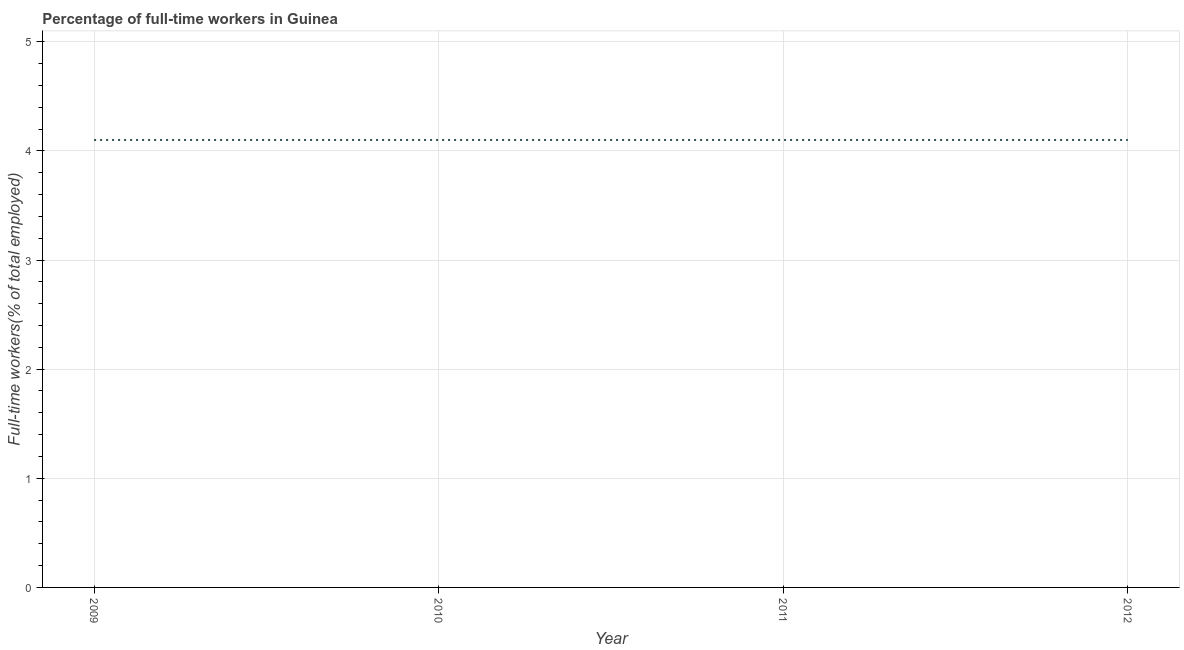What is the percentage of full-time workers in 2009?
Offer a very short reply. 4.1. Across all years, what is the maximum percentage of full-time workers?
Your response must be concise. 4.1. Across all years, what is the minimum percentage of full-time workers?
Make the answer very short. 4.1. In which year was the percentage of full-time workers maximum?
Make the answer very short. 2009. In which year was the percentage of full-time workers minimum?
Your answer should be compact. 2009. What is the sum of the percentage of full-time workers?
Offer a terse response. 16.4. What is the average percentage of full-time workers per year?
Ensure brevity in your answer.  4.1. What is the median percentage of full-time workers?
Ensure brevity in your answer.  4.1. Do a majority of the years between 2010 and 2012 (inclusive) have percentage of full-time workers greater than 2 %?
Provide a succinct answer. Yes. What is the ratio of the percentage of full-time workers in 2010 to that in 2011?
Offer a very short reply. 1. Is the sum of the percentage of full-time workers in 2009 and 2011 greater than the maximum percentage of full-time workers across all years?
Your answer should be compact. Yes. What is the difference between the highest and the lowest percentage of full-time workers?
Give a very brief answer. 0. In how many years, is the percentage of full-time workers greater than the average percentage of full-time workers taken over all years?
Offer a terse response. 0. How many lines are there?
Provide a short and direct response. 1. How many years are there in the graph?
Offer a very short reply. 4. Are the values on the major ticks of Y-axis written in scientific E-notation?
Keep it short and to the point. No. What is the title of the graph?
Ensure brevity in your answer.  Percentage of full-time workers in Guinea. What is the label or title of the X-axis?
Your answer should be compact. Year. What is the label or title of the Y-axis?
Your answer should be compact. Full-time workers(% of total employed). What is the Full-time workers(% of total employed) in 2009?
Provide a short and direct response. 4.1. What is the Full-time workers(% of total employed) of 2010?
Provide a succinct answer. 4.1. What is the Full-time workers(% of total employed) of 2011?
Make the answer very short. 4.1. What is the Full-time workers(% of total employed) of 2012?
Ensure brevity in your answer.  4.1. What is the difference between the Full-time workers(% of total employed) in 2009 and 2010?
Keep it short and to the point. 0. What is the difference between the Full-time workers(% of total employed) in 2009 and 2012?
Make the answer very short. 0. What is the difference between the Full-time workers(% of total employed) in 2010 and 2012?
Your answer should be compact. 0. What is the difference between the Full-time workers(% of total employed) in 2011 and 2012?
Ensure brevity in your answer.  0. What is the ratio of the Full-time workers(% of total employed) in 2009 to that in 2010?
Your answer should be very brief. 1. What is the ratio of the Full-time workers(% of total employed) in 2009 to that in 2012?
Offer a very short reply. 1. What is the ratio of the Full-time workers(% of total employed) in 2010 to that in 2011?
Your answer should be compact. 1. What is the ratio of the Full-time workers(% of total employed) in 2010 to that in 2012?
Provide a short and direct response. 1. What is the ratio of the Full-time workers(% of total employed) in 2011 to that in 2012?
Your response must be concise. 1. 